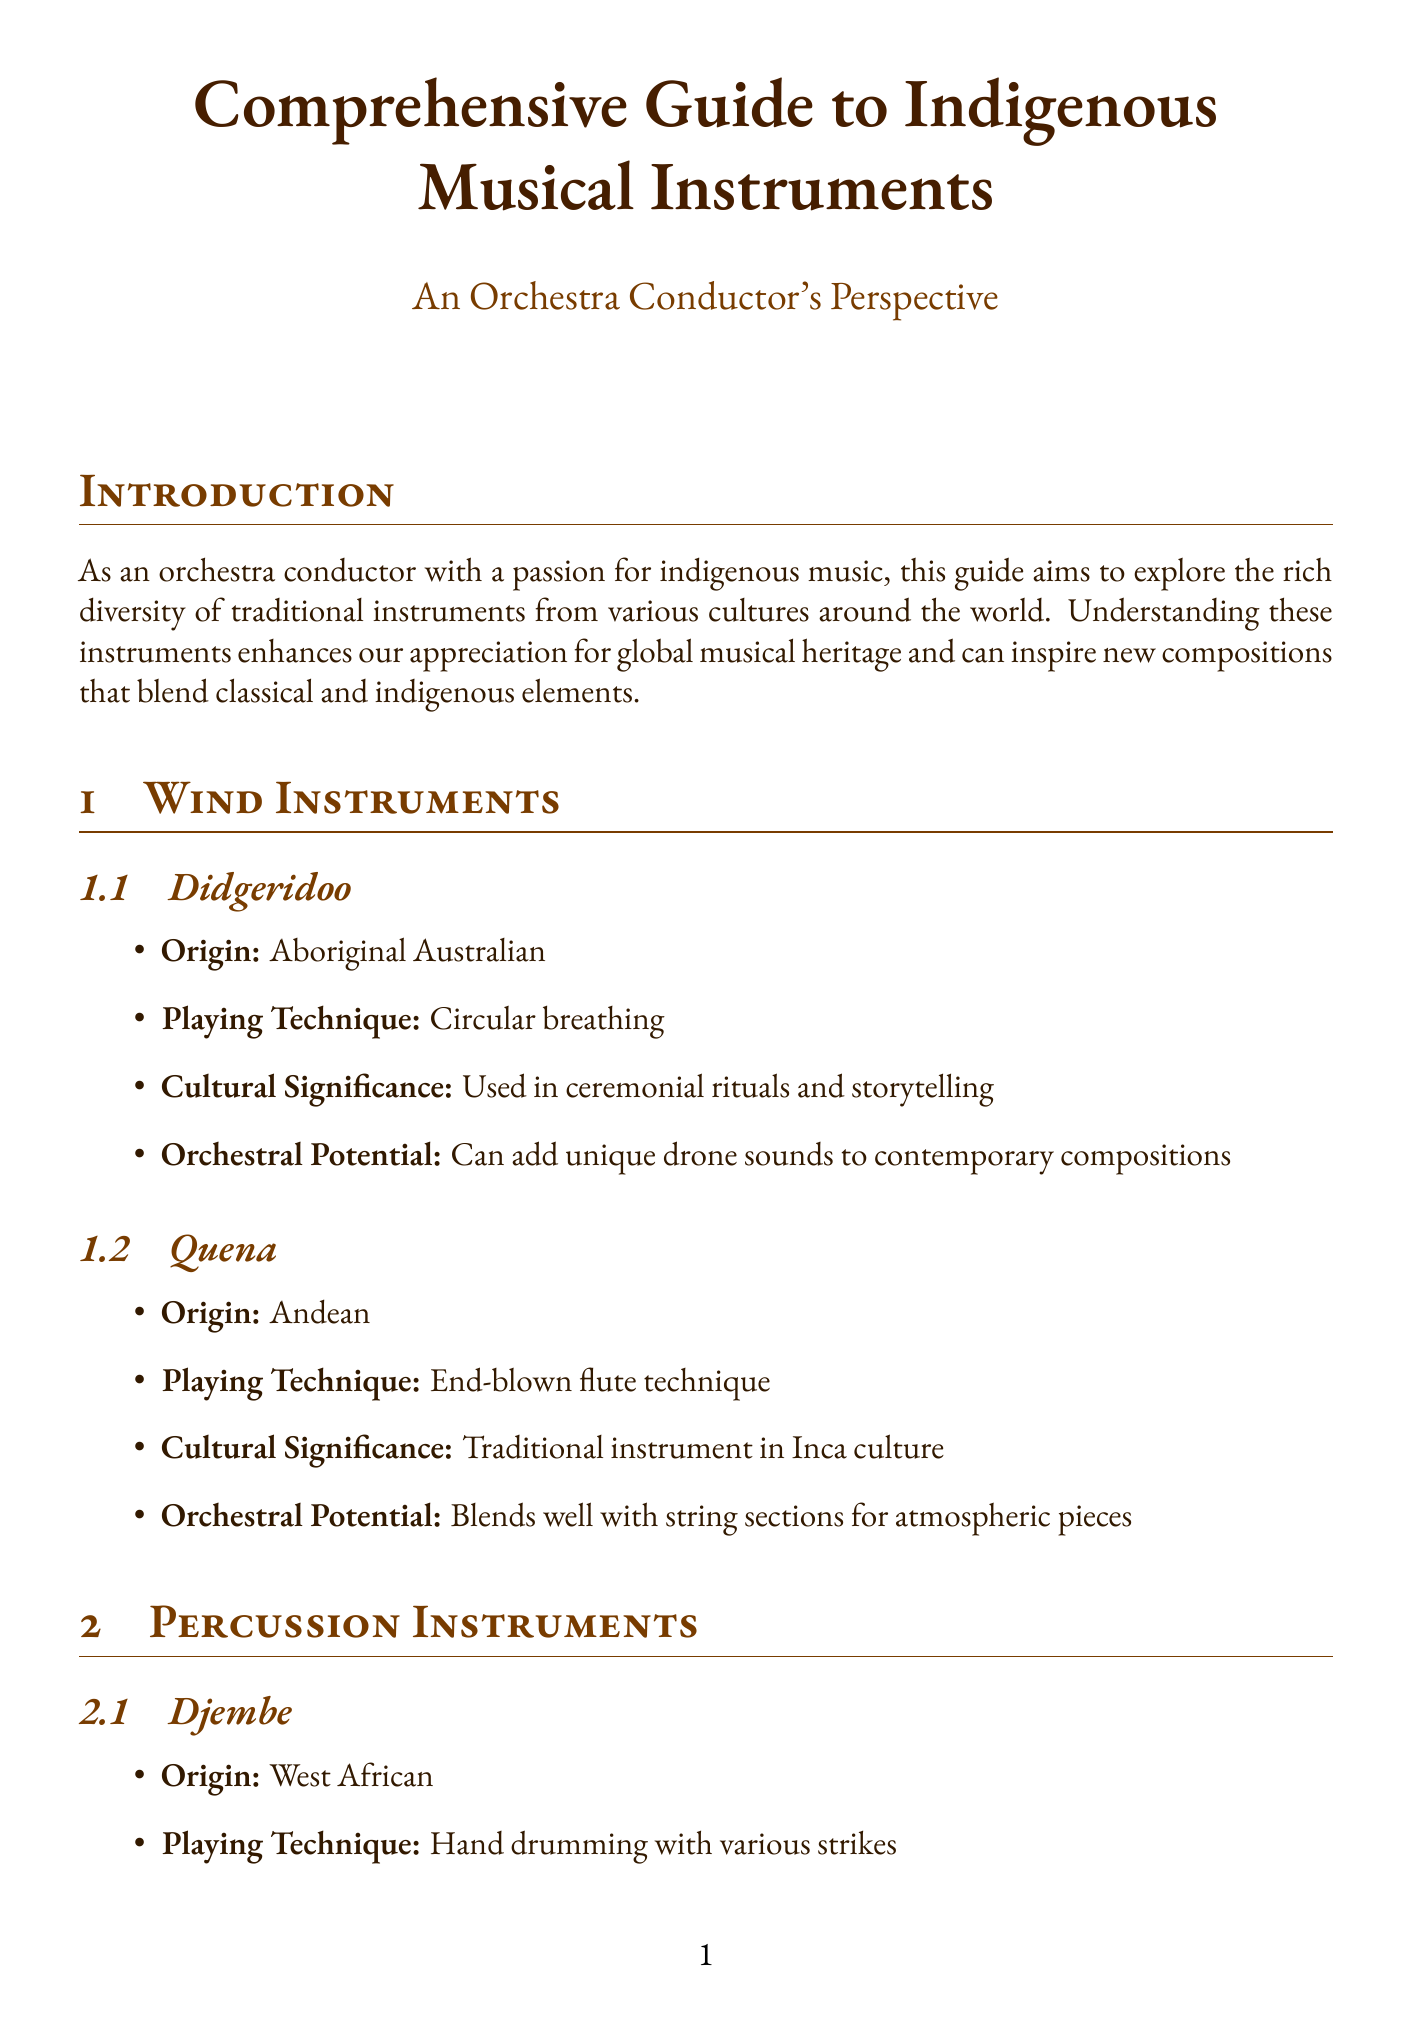What is the origin of the Didgeridoo? The Didgeridoo is identified as an Aboriginal Australian instrument.
Answer: Aboriginal Australian What playing technique is used for the Quena? The Quena is played using the end-blown flute technique.
Answer: End-blown flute technique What is the cultural significance of the Djembe? The Djembe is used in social gatherings and traditional ceremonies.
Answer: Used in social gatherings and traditional ceremonies Which indigenous instrument is essential in Hindustani classical music? The Sitar is noted as essential in Hindustani classical music.
Answer: Sitar How can indigenous instruments enhance orchestral performances? They can add unique rhythmic elements, textural backgrounds, or exotic melodies and harmonics.
Answer: Add unique rhythmic elements, textural backgrounds, or exotic melodies and harmonics What methods are suggested for preserving indigenous musical traditions? Suggested methods include collaborating with indigenous musicians, incorporating instruments in education, and organizing workshops.
Answer: Collaborating with indigenous musicians, incorporating instruments in education, and organizing workshops What type of contemporary applications are mentioned for indigenous instruments in orchestras? The document mentions creating fusion pieces, commissioning new works, and exploring microtonal possibilities.
Answer: Creating fusion pieces, commissioning new works, and exploring microtonal possibilities Which countries do the Gamelan and Djembe originate from? The Gamelan is from Indonesia and the Djembe is from West Africa.
Answer: Indonesia and West Africa 